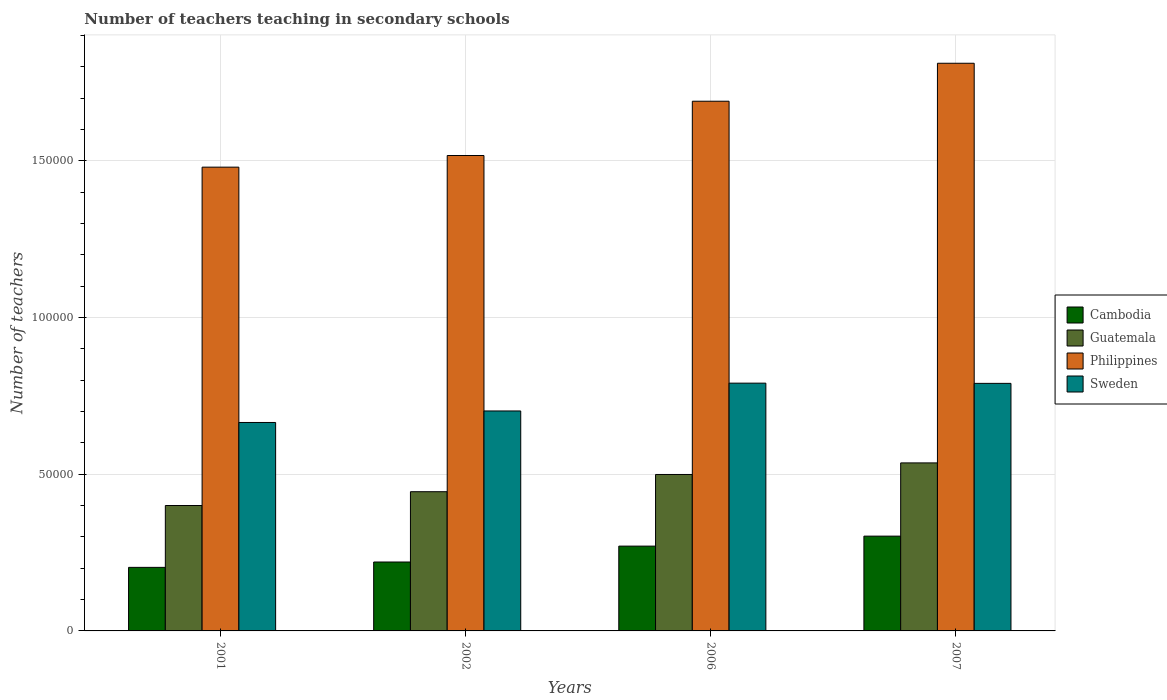Are the number of bars on each tick of the X-axis equal?
Keep it short and to the point. Yes. How many bars are there on the 1st tick from the right?
Your answer should be compact. 4. In how many cases, is the number of bars for a given year not equal to the number of legend labels?
Your answer should be very brief. 0. What is the number of teachers teaching in secondary schools in Philippines in 2001?
Offer a terse response. 1.48e+05. Across all years, what is the maximum number of teachers teaching in secondary schools in Cambodia?
Make the answer very short. 3.03e+04. Across all years, what is the minimum number of teachers teaching in secondary schools in Cambodia?
Give a very brief answer. 2.03e+04. In which year was the number of teachers teaching in secondary schools in Guatemala maximum?
Provide a short and direct response. 2007. What is the total number of teachers teaching in secondary schools in Sweden in the graph?
Your answer should be very brief. 2.95e+05. What is the difference between the number of teachers teaching in secondary schools in Guatemala in 2001 and that in 2006?
Ensure brevity in your answer.  -9906. What is the difference between the number of teachers teaching in secondary schools in Cambodia in 2007 and the number of teachers teaching in secondary schools in Guatemala in 2001?
Your answer should be very brief. -9771. What is the average number of teachers teaching in secondary schools in Guatemala per year?
Offer a very short reply. 4.70e+04. In the year 2006, what is the difference between the number of teachers teaching in secondary schools in Cambodia and number of teachers teaching in secondary schools in Philippines?
Your answer should be very brief. -1.42e+05. What is the ratio of the number of teachers teaching in secondary schools in Sweden in 2001 to that in 2007?
Your answer should be very brief. 0.84. Is the difference between the number of teachers teaching in secondary schools in Cambodia in 2006 and 2007 greater than the difference between the number of teachers teaching in secondary schools in Philippines in 2006 and 2007?
Give a very brief answer. Yes. What is the difference between the highest and the second highest number of teachers teaching in secondary schools in Guatemala?
Provide a short and direct response. 3695. What is the difference between the highest and the lowest number of teachers teaching in secondary schools in Sweden?
Keep it short and to the point. 1.25e+04. What does the 2nd bar from the left in 2006 represents?
Provide a succinct answer. Guatemala. Is it the case that in every year, the sum of the number of teachers teaching in secondary schools in Cambodia and number of teachers teaching in secondary schools in Sweden is greater than the number of teachers teaching in secondary schools in Guatemala?
Your response must be concise. Yes. How many bars are there?
Offer a very short reply. 16. Are the values on the major ticks of Y-axis written in scientific E-notation?
Keep it short and to the point. No. Does the graph contain any zero values?
Your answer should be compact. No. How are the legend labels stacked?
Offer a terse response. Vertical. What is the title of the graph?
Your answer should be compact. Number of teachers teaching in secondary schools. Does "Azerbaijan" appear as one of the legend labels in the graph?
Keep it short and to the point. No. What is the label or title of the X-axis?
Offer a terse response. Years. What is the label or title of the Y-axis?
Keep it short and to the point. Number of teachers. What is the Number of teachers in Cambodia in 2001?
Ensure brevity in your answer.  2.03e+04. What is the Number of teachers of Guatemala in 2001?
Provide a succinct answer. 4.00e+04. What is the Number of teachers in Philippines in 2001?
Offer a terse response. 1.48e+05. What is the Number of teachers of Sweden in 2001?
Your answer should be compact. 6.65e+04. What is the Number of teachers of Cambodia in 2002?
Provide a succinct answer. 2.20e+04. What is the Number of teachers of Guatemala in 2002?
Make the answer very short. 4.44e+04. What is the Number of teachers in Philippines in 2002?
Your answer should be compact. 1.52e+05. What is the Number of teachers in Sweden in 2002?
Your answer should be very brief. 7.02e+04. What is the Number of teachers in Cambodia in 2006?
Provide a succinct answer. 2.71e+04. What is the Number of teachers of Guatemala in 2006?
Give a very brief answer. 4.99e+04. What is the Number of teachers in Philippines in 2006?
Provide a succinct answer. 1.69e+05. What is the Number of teachers of Sweden in 2006?
Give a very brief answer. 7.91e+04. What is the Number of teachers in Cambodia in 2007?
Make the answer very short. 3.03e+04. What is the Number of teachers of Guatemala in 2007?
Offer a very short reply. 5.36e+04. What is the Number of teachers in Philippines in 2007?
Provide a short and direct response. 1.81e+05. What is the Number of teachers of Sweden in 2007?
Keep it short and to the point. 7.90e+04. Across all years, what is the maximum Number of teachers in Cambodia?
Ensure brevity in your answer.  3.03e+04. Across all years, what is the maximum Number of teachers in Guatemala?
Give a very brief answer. 5.36e+04. Across all years, what is the maximum Number of teachers of Philippines?
Provide a succinct answer. 1.81e+05. Across all years, what is the maximum Number of teachers in Sweden?
Make the answer very short. 7.91e+04. Across all years, what is the minimum Number of teachers in Cambodia?
Provide a short and direct response. 2.03e+04. Across all years, what is the minimum Number of teachers in Guatemala?
Offer a very short reply. 4.00e+04. Across all years, what is the minimum Number of teachers in Philippines?
Provide a short and direct response. 1.48e+05. Across all years, what is the minimum Number of teachers in Sweden?
Make the answer very short. 6.65e+04. What is the total Number of teachers of Cambodia in the graph?
Offer a very short reply. 9.96e+04. What is the total Number of teachers in Guatemala in the graph?
Keep it short and to the point. 1.88e+05. What is the total Number of teachers in Philippines in the graph?
Make the answer very short. 6.50e+05. What is the total Number of teachers of Sweden in the graph?
Offer a terse response. 2.95e+05. What is the difference between the Number of teachers of Cambodia in 2001 and that in 2002?
Offer a very short reply. -1711. What is the difference between the Number of teachers in Guatemala in 2001 and that in 2002?
Your answer should be compact. -4406. What is the difference between the Number of teachers of Philippines in 2001 and that in 2002?
Your answer should be compact. -3717. What is the difference between the Number of teachers of Sweden in 2001 and that in 2002?
Make the answer very short. -3673. What is the difference between the Number of teachers in Cambodia in 2001 and that in 2006?
Ensure brevity in your answer.  -6784. What is the difference between the Number of teachers in Guatemala in 2001 and that in 2006?
Your response must be concise. -9906. What is the difference between the Number of teachers of Philippines in 2001 and that in 2006?
Your response must be concise. -2.10e+04. What is the difference between the Number of teachers of Sweden in 2001 and that in 2006?
Keep it short and to the point. -1.25e+04. What is the difference between the Number of teachers of Cambodia in 2001 and that in 2007?
Offer a very short reply. -9972. What is the difference between the Number of teachers of Guatemala in 2001 and that in 2007?
Your response must be concise. -1.36e+04. What is the difference between the Number of teachers in Philippines in 2001 and that in 2007?
Make the answer very short. -3.32e+04. What is the difference between the Number of teachers in Sweden in 2001 and that in 2007?
Your answer should be very brief. -1.25e+04. What is the difference between the Number of teachers in Cambodia in 2002 and that in 2006?
Your response must be concise. -5073. What is the difference between the Number of teachers of Guatemala in 2002 and that in 2006?
Provide a short and direct response. -5500. What is the difference between the Number of teachers in Philippines in 2002 and that in 2006?
Provide a succinct answer. -1.73e+04. What is the difference between the Number of teachers of Sweden in 2002 and that in 2006?
Your answer should be compact. -8876. What is the difference between the Number of teachers of Cambodia in 2002 and that in 2007?
Make the answer very short. -8261. What is the difference between the Number of teachers in Guatemala in 2002 and that in 2007?
Provide a succinct answer. -9195. What is the difference between the Number of teachers in Philippines in 2002 and that in 2007?
Offer a terse response. -2.94e+04. What is the difference between the Number of teachers of Sweden in 2002 and that in 2007?
Give a very brief answer. -8807. What is the difference between the Number of teachers in Cambodia in 2006 and that in 2007?
Offer a very short reply. -3188. What is the difference between the Number of teachers of Guatemala in 2006 and that in 2007?
Provide a short and direct response. -3695. What is the difference between the Number of teachers in Philippines in 2006 and that in 2007?
Your answer should be compact. -1.21e+04. What is the difference between the Number of teachers of Sweden in 2006 and that in 2007?
Give a very brief answer. 69. What is the difference between the Number of teachers in Cambodia in 2001 and the Number of teachers in Guatemala in 2002?
Give a very brief answer. -2.41e+04. What is the difference between the Number of teachers of Cambodia in 2001 and the Number of teachers of Philippines in 2002?
Offer a terse response. -1.31e+05. What is the difference between the Number of teachers in Cambodia in 2001 and the Number of teachers in Sweden in 2002?
Provide a short and direct response. -4.99e+04. What is the difference between the Number of teachers of Guatemala in 2001 and the Number of teachers of Philippines in 2002?
Your response must be concise. -1.12e+05. What is the difference between the Number of teachers in Guatemala in 2001 and the Number of teachers in Sweden in 2002?
Keep it short and to the point. -3.02e+04. What is the difference between the Number of teachers of Philippines in 2001 and the Number of teachers of Sweden in 2002?
Give a very brief answer. 7.78e+04. What is the difference between the Number of teachers in Cambodia in 2001 and the Number of teachers in Guatemala in 2006?
Make the answer very short. -2.96e+04. What is the difference between the Number of teachers of Cambodia in 2001 and the Number of teachers of Philippines in 2006?
Give a very brief answer. -1.49e+05. What is the difference between the Number of teachers of Cambodia in 2001 and the Number of teachers of Sweden in 2006?
Offer a very short reply. -5.88e+04. What is the difference between the Number of teachers of Guatemala in 2001 and the Number of teachers of Philippines in 2006?
Keep it short and to the point. -1.29e+05. What is the difference between the Number of teachers of Guatemala in 2001 and the Number of teachers of Sweden in 2006?
Your answer should be very brief. -3.91e+04. What is the difference between the Number of teachers in Philippines in 2001 and the Number of teachers in Sweden in 2006?
Make the answer very short. 6.89e+04. What is the difference between the Number of teachers in Cambodia in 2001 and the Number of teachers in Guatemala in 2007?
Your answer should be compact. -3.33e+04. What is the difference between the Number of teachers in Cambodia in 2001 and the Number of teachers in Philippines in 2007?
Provide a succinct answer. -1.61e+05. What is the difference between the Number of teachers of Cambodia in 2001 and the Number of teachers of Sweden in 2007?
Offer a terse response. -5.87e+04. What is the difference between the Number of teachers of Guatemala in 2001 and the Number of teachers of Philippines in 2007?
Make the answer very short. -1.41e+05. What is the difference between the Number of teachers of Guatemala in 2001 and the Number of teachers of Sweden in 2007?
Make the answer very short. -3.90e+04. What is the difference between the Number of teachers of Philippines in 2001 and the Number of teachers of Sweden in 2007?
Your answer should be very brief. 6.90e+04. What is the difference between the Number of teachers in Cambodia in 2002 and the Number of teachers in Guatemala in 2006?
Make the answer very short. -2.79e+04. What is the difference between the Number of teachers in Cambodia in 2002 and the Number of teachers in Philippines in 2006?
Your answer should be very brief. -1.47e+05. What is the difference between the Number of teachers in Cambodia in 2002 and the Number of teachers in Sweden in 2006?
Your answer should be very brief. -5.71e+04. What is the difference between the Number of teachers of Guatemala in 2002 and the Number of teachers of Philippines in 2006?
Provide a succinct answer. -1.25e+05. What is the difference between the Number of teachers of Guatemala in 2002 and the Number of teachers of Sweden in 2006?
Provide a short and direct response. -3.46e+04. What is the difference between the Number of teachers of Philippines in 2002 and the Number of teachers of Sweden in 2006?
Your answer should be very brief. 7.27e+04. What is the difference between the Number of teachers of Cambodia in 2002 and the Number of teachers of Guatemala in 2007?
Your response must be concise. -3.16e+04. What is the difference between the Number of teachers in Cambodia in 2002 and the Number of teachers in Philippines in 2007?
Provide a short and direct response. -1.59e+05. What is the difference between the Number of teachers in Cambodia in 2002 and the Number of teachers in Sweden in 2007?
Offer a terse response. -5.70e+04. What is the difference between the Number of teachers in Guatemala in 2002 and the Number of teachers in Philippines in 2007?
Provide a short and direct response. -1.37e+05. What is the difference between the Number of teachers of Guatemala in 2002 and the Number of teachers of Sweden in 2007?
Make the answer very short. -3.46e+04. What is the difference between the Number of teachers of Philippines in 2002 and the Number of teachers of Sweden in 2007?
Your answer should be compact. 7.27e+04. What is the difference between the Number of teachers of Cambodia in 2006 and the Number of teachers of Guatemala in 2007?
Ensure brevity in your answer.  -2.66e+04. What is the difference between the Number of teachers of Cambodia in 2006 and the Number of teachers of Philippines in 2007?
Make the answer very short. -1.54e+05. What is the difference between the Number of teachers of Cambodia in 2006 and the Number of teachers of Sweden in 2007?
Your answer should be compact. -5.19e+04. What is the difference between the Number of teachers of Guatemala in 2006 and the Number of teachers of Philippines in 2007?
Offer a very short reply. -1.31e+05. What is the difference between the Number of teachers of Guatemala in 2006 and the Number of teachers of Sweden in 2007?
Your response must be concise. -2.91e+04. What is the difference between the Number of teachers in Philippines in 2006 and the Number of teachers in Sweden in 2007?
Provide a succinct answer. 9.01e+04. What is the average Number of teachers of Cambodia per year?
Provide a short and direct response. 2.49e+04. What is the average Number of teachers of Guatemala per year?
Keep it short and to the point. 4.70e+04. What is the average Number of teachers in Philippines per year?
Provide a succinct answer. 1.63e+05. What is the average Number of teachers of Sweden per year?
Ensure brevity in your answer.  7.37e+04. In the year 2001, what is the difference between the Number of teachers of Cambodia and Number of teachers of Guatemala?
Offer a terse response. -1.97e+04. In the year 2001, what is the difference between the Number of teachers in Cambodia and Number of teachers in Philippines?
Make the answer very short. -1.28e+05. In the year 2001, what is the difference between the Number of teachers of Cambodia and Number of teachers of Sweden?
Offer a very short reply. -4.62e+04. In the year 2001, what is the difference between the Number of teachers in Guatemala and Number of teachers in Philippines?
Make the answer very short. -1.08e+05. In the year 2001, what is the difference between the Number of teachers in Guatemala and Number of teachers in Sweden?
Offer a very short reply. -2.65e+04. In the year 2001, what is the difference between the Number of teachers of Philippines and Number of teachers of Sweden?
Provide a succinct answer. 8.15e+04. In the year 2002, what is the difference between the Number of teachers of Cambodia and Number of teachers of Guatemala?
Make the answer very short. -2.24e+04. In the year 2002, what is the difference between the Number of teachers in Cambodia and Number of teachers in Philippines?
Keep it short and to the point. -1.30e+05. In the year 2002, what is the difference between the Number of teachers of Cambodia and Number of teachers of Sweden?
Your answer should be compact. -4.82e+04. In the year 2002, what is the difference between the Number of teachers in Guatemala and Number of teachers in Philippines?
Your answer should be very brief. -1.07e+05. In the year 2002, what is the difference between the Number of teachers in Guatemala and Number of teachers in Sweden?
Your response must be concise. -2.58e+04. In the year 2002, what is the difference between the Number of teachers of Philippines and Number of teachers of Sweden?
Offer a very short reply. 8.15e+04. In the year 2006, what is the difference between the Number of teachers of Cambodia and Number of teachers of Guatemala?
Your response must be concise. -2.29e+04. In the year 2006, what is the difference between the Number of teachers of Cambodia and Number of teachers of Philippines?
Your response must be concise. -1.42e+05. In the year 2006, what is the difference between the Number of teachers of Cambodia and Number of teachers of Sweden?
Make the answer very short. -5.20e+04. In the year 2006, what is the difference between the Number of teachers of Guatemala and Number of teachers of Philippines?
Keep it short and to the point. -1.19e+05. In the year 2006, what is the difference between the Number of teachers in Guatemala and Number of teachers in Sweden?
Keep it short and to the point. -2.92e+04. In the year 2006, what is the difference between the Number of teachers of Philippines and Number of teachers of Sweden?
Keep it short and to the point. 9.00e+04. In the year 2007, what is the difference between the Number of teachers in Cambodia and Number of teachers in Guatemala?
Offer a very short reply. -2.34e+04. In the year 2007, what is the difference between the Number of teachers of Cambodia and Number of teachers of Philippines?
Provide a short and direct response. -1.51e+05. In the year 2007, what is the difference between the Number of teachers in Cambodia and Number of teachers in Sweden?
Your answer should be compact. -4.88e+04. In the year 2007, what is the difference between the Number of teachers in Guatemala and Number of teachers in Philippines?
Your answer should be very brief. -1.28e+05. In the year 2007, what is the difference between the Number of teachers in Guatemala and Number of teachers in Sweden?
Give a very brief answer. -2.54e+04. In the year 2007, what is the difference between the Number of teachers in Philippines and Number of teachers in Sweden?
Keep it short and to the point. 1.02e+05. What is the ratio of the Number of teachers in Cambodia in 2001 to that in 2002?
Make the answer very short. 0.92. What is the ratio of the Number of teachers in Guatemala in 2001 to that in 2002?
Make the answer very short. 0.9. What is the ratio of the Number of teachers of Philippines in 2001 to that in 2002?
Offer a terse response. 0.98. What is the ratio of the Number of teachers in Sweden in 2001 to that in 2002?
Provide a succinct answer. 0.95. What is the ratio of the Number of teachers of Cambodia in 2001 to that in 2006?
Provide a short and direct response. 0.75. What is the ratio of the Number of teachers of Guatemala in 2001 to that in 2006?
Make the answer very short. 0.8. What is the ratio of the Number of teachers in Philippines in 2001 to that in 2006?
Your answer should be compact. 0.88. What is the ratio of the Number of teachers of Sweden in 2001 to that in 2006?
Your answer should be compact. 0.84. What is the ratio of the Number of teachers of Cambodia in 2001 to that in 2007?
Your answer should be compact. 0.67. What is the ratio of the Number of teachers in Guatemala in 2001 to that in 2007?
Your answer should be compact. 0.75. What is the ratio of the Number of teachers in Philippines in 2001 to that in 2007?
Your answer should be compact. 0.82. What is the ratio of the Number of teachers of Sweden in 2001 to that in 2007?
Your answer should be very brief. 0.84. What is the ratio of the Number of teachers in Cambodia in 2002 to that in 2006?
Offer a terse response. 0.81. What is the ratio of the Number of teachers in Guatemala in 2002 to that in 2006?
Ensure brevity in your answer.  0.89. What is the ratio of the Number of teachers in Philippines in 2002 to that in 2006?
Make the answer very short. 0.9. What is the ratio of the Number of teachers in Sweden in 2002 to that in 2006?
Offer a terse response. 0.89. What is the ratio of the Number of teachers of Cambodia in 2002 to that in 2007?
Your answer should be compact. 0.73. What is the ratio of the Number of teachers of Guatemala in 2002 to that in 2007?
Provide a short and direct response. 0.83. What is the ratio of the Number of teachers in Philippines in 2002 to that in 2007?
Keep it short and to the point. 0.84. What is the ratio of the Number of teachers in Sweden in 2002 to that in 2007?
Your answer should be very brief. 0.89. What is the ratio of the Number of teachers in Cambodia in 2006 to that in 2007?
Provide a succinct answer. 0.89. What is the ratio of the Number of teachers in Guatemala in 2006 to that in 2007?
Your answer should be very brief. 0.93. What is the ratio of the Number of teachers in Philippines in 2006 to that in 2007?
Make the answer very short. 0.93. What is the ratio of the Number of teachers in Sweden in 2006 to that in 2007?
Your answer should be compact. 1. What is the difference between the highest and the second highest Number of teachers in Cambodia?
Your answer should be very brief. 3188. What is the difference between the highest and the second highest Number of teachers in Guatemala?
Your response must be concise. 3695. What is the difference between the highest and the second highest Number of teachers of Philippines?
Ensure brevity in your answer.  1.21e+04. What is the difference between the highest and the lowest Number of teachers of Cambodia?
Keep it short and to the point. 9972. What is the difference between the highest and the lowest Number of teachers of Guatemala?
Your answer should be compact. 1.36e+04. What is the difference between the highest and the lowest Number of teachers in Philippines?
Keep it short and to the point. 3.32e+04. What is the difference between the highest and the lowest Number of teachers in Sweden?
Offer a very short reply. 1.25e+04. 